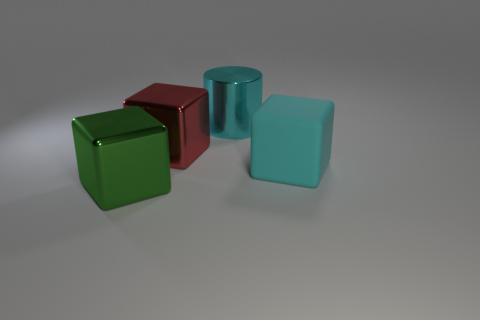Is there anything else that has the same shape as the large cyan shiny thing? Upon examining the image, it appears there isn't an exact match in shape to the large cyan cylinder. However, there is a smaller cube that shares a similar color but differs in shape, highlighting a diversity of geometric forms. 